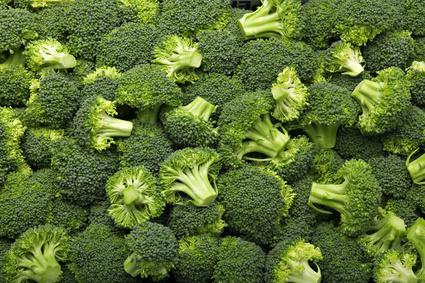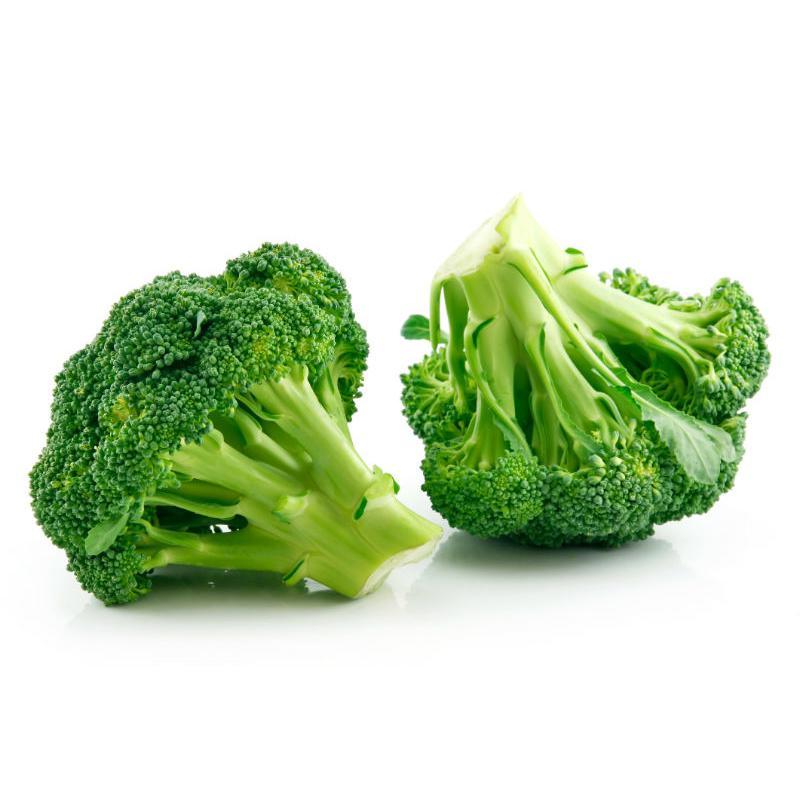The first image is the image on the left, the second image is the image on the right. Examine the images to the left and right. Is the description "The broccoli on the right is a brighter green than on the left." accurate? Answer yes or no. Yes. The first image is the image on the left, the second image is the image on the right. Given the left and right images, does the statement "No image contains more than five cut pieces of broccoli." hold true? Answer yes or no. No. 